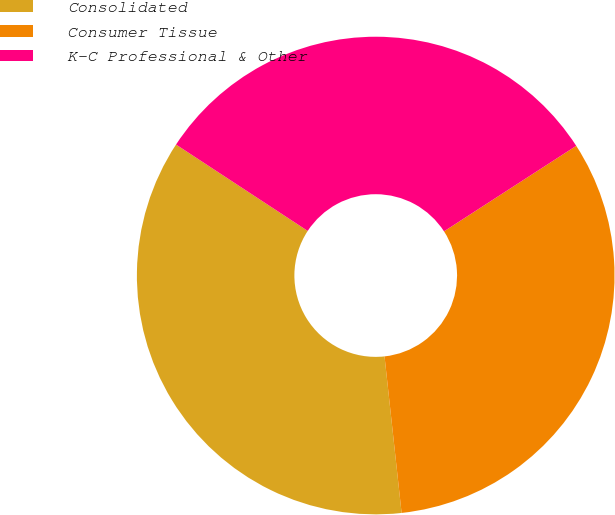Convert chart to OTSL. <chart><loc_0><loc_0><loc_500><loc_500><pie_chart><fcel>Consolidated<fcel>Consumer Tissue<fcel>K-C Professional & Other<nl><fcel>35.97%<fcel>32.41%<fcel>31.62%<nl></chart> 